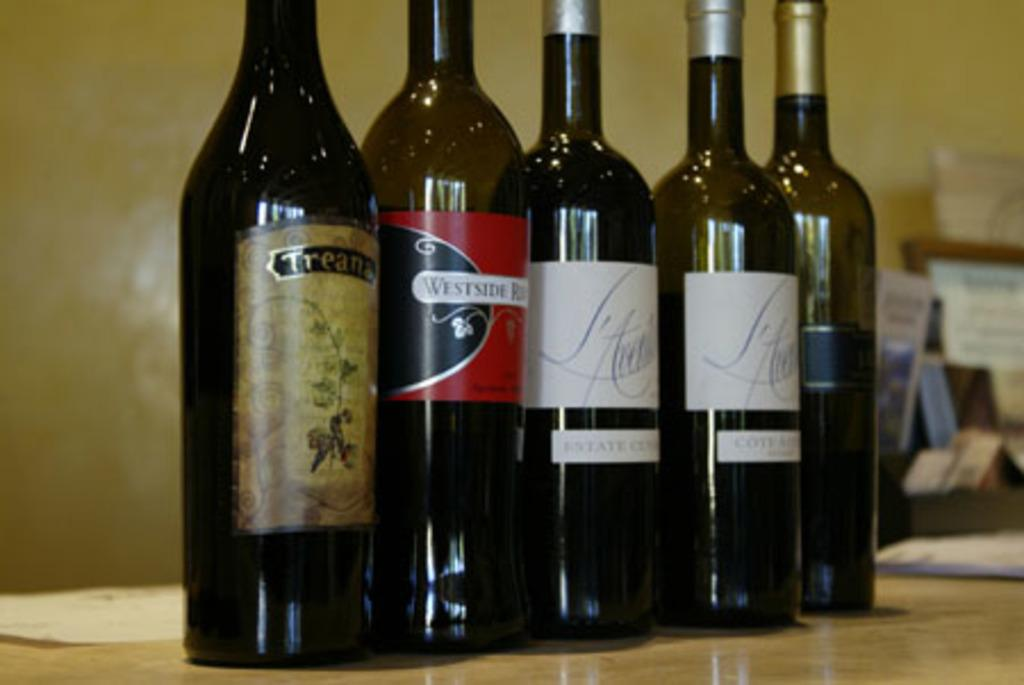<image>
Relay a brief, clear account of the picture shown. A tall bottle of Westside sits among a row of wines. 